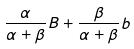<formula> <loc_0><loc_0><loc_500><loc_500>\frac { \alpha } { \alpha + \beta } B + \frac { \beta } { \alpha + \beta } b</formula> 